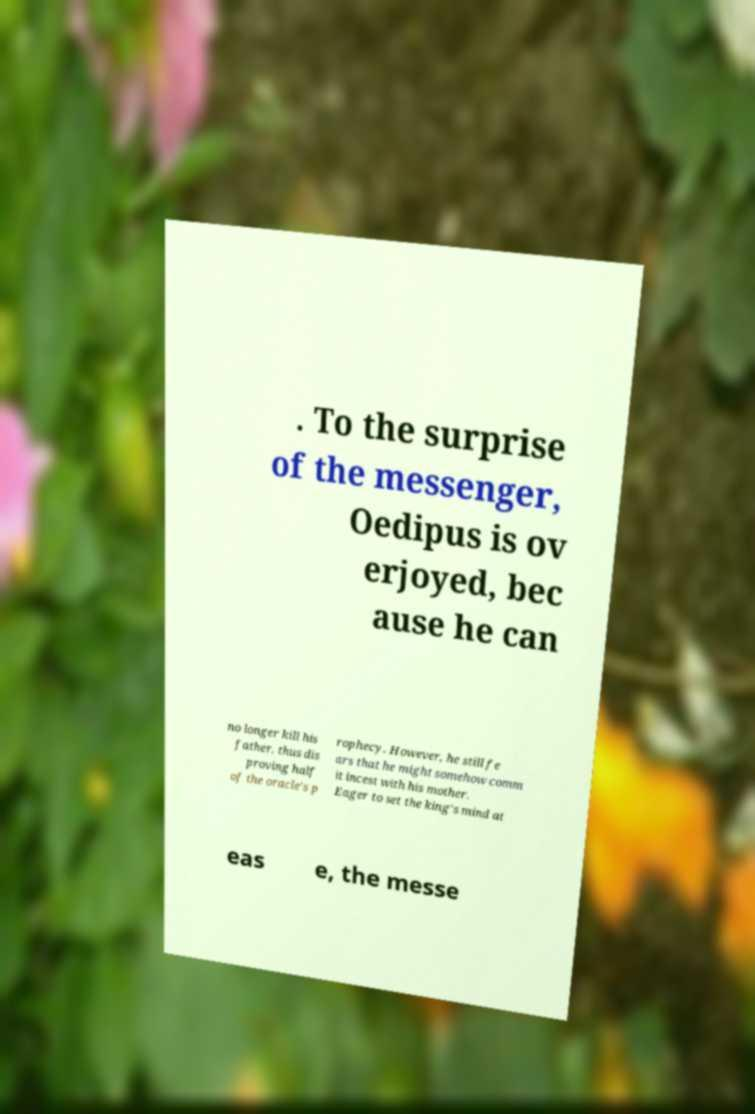Can you read and provide the text displayed in the image?This photo seems to have some interesting text. Can you extract and type it out for me? . To the surprise of the messenger, Oedipus is ov erjoyed, bec ause he can no longer kill his father, thus dis proving half of the oracle's p rophecy. However, he still fe ars that he might somehow comm it incest with his mother. Eager to set the king's mind at eas e, the messe 